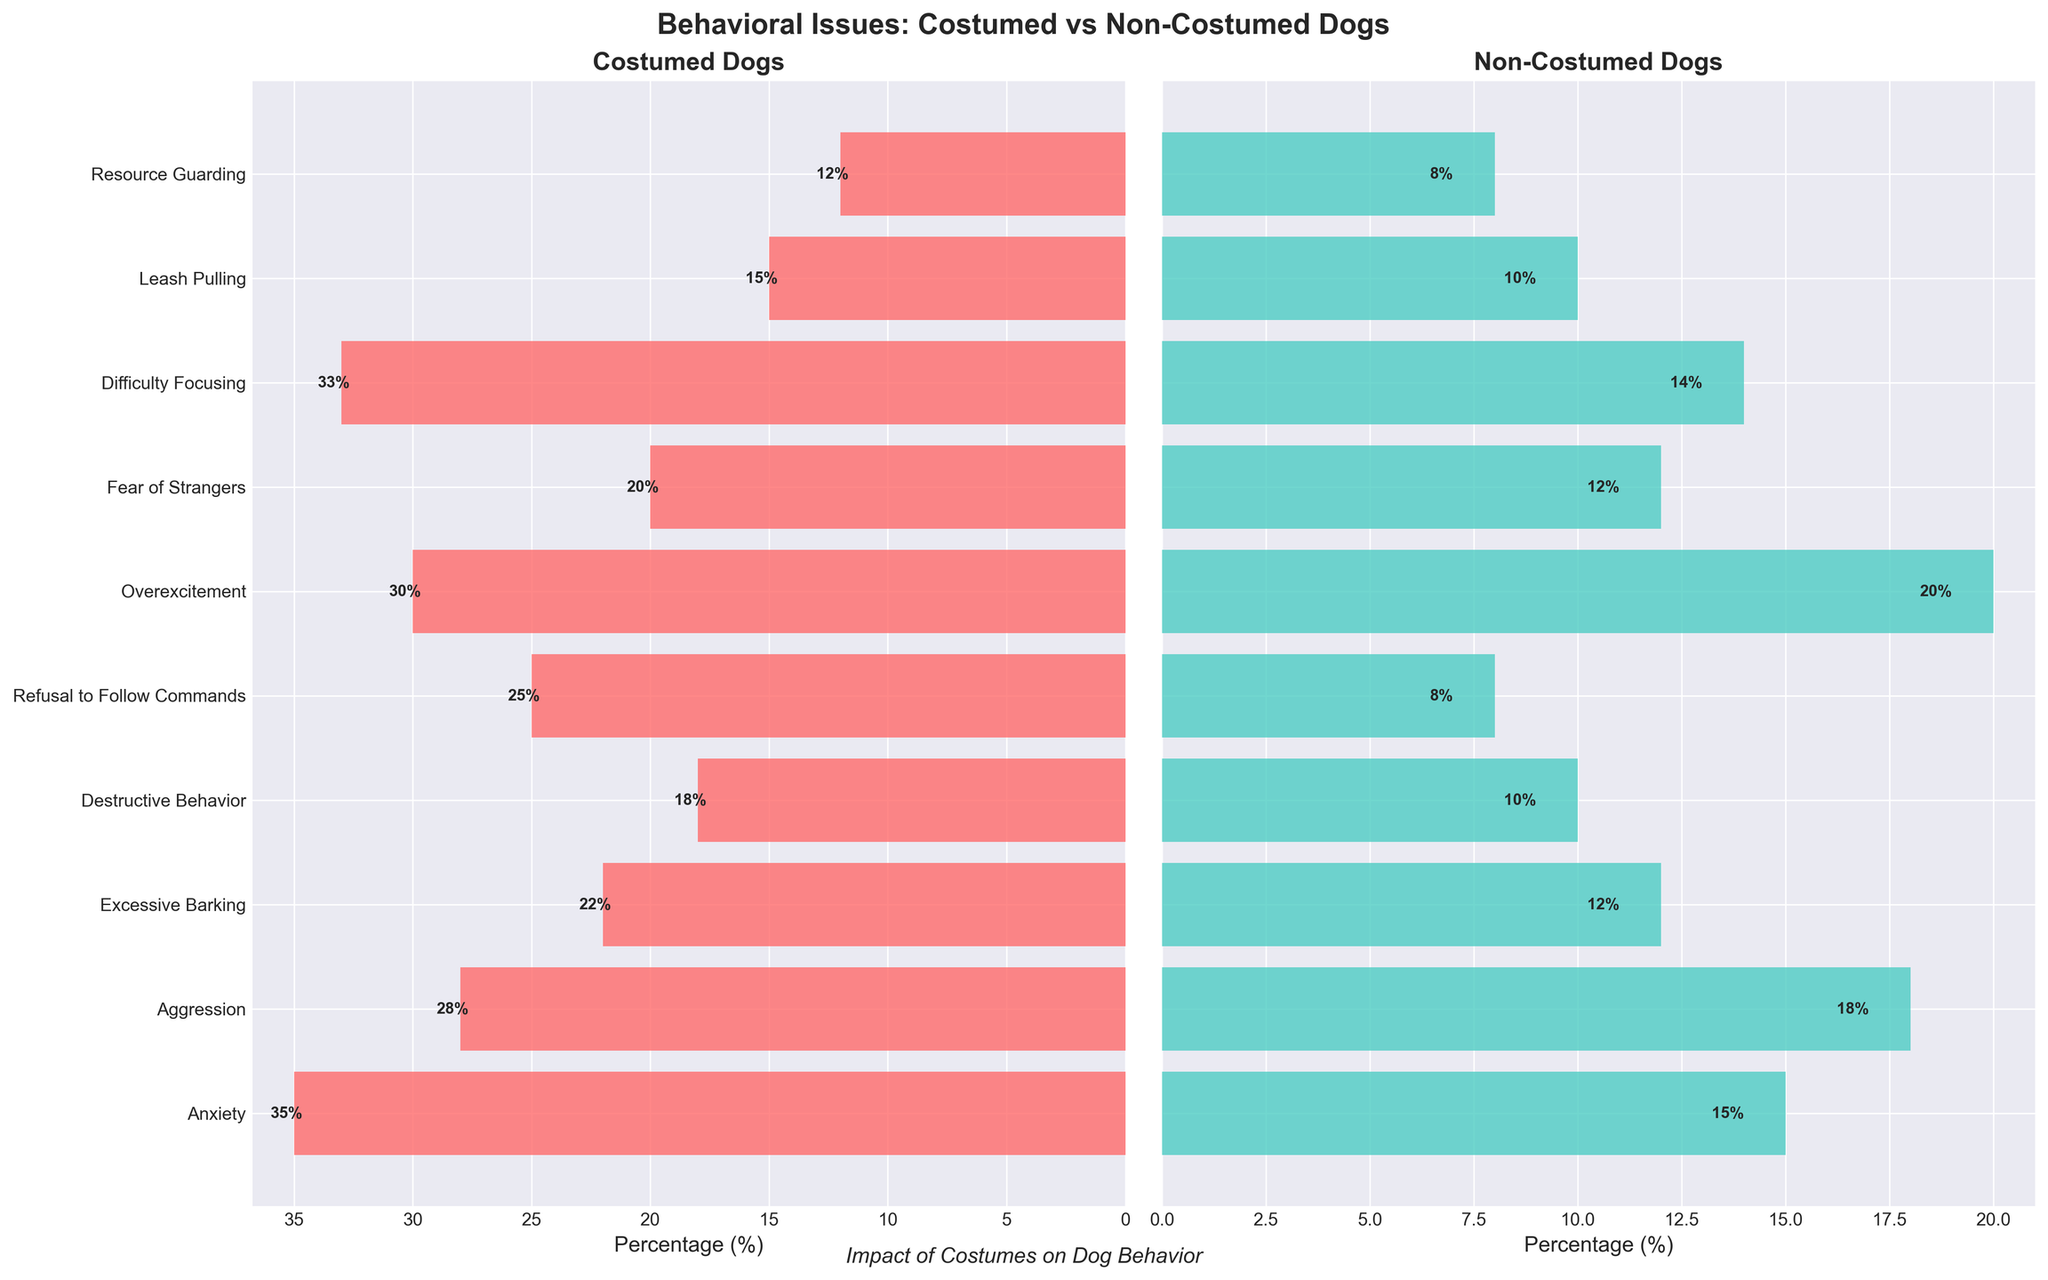What is the title of the figure? The title of the figure is written above the two subplots. It reads 'Behavioral Issues: Costumed vs Non-Costumed Dogs'.
Answer: Behavioral Issues: Costumed vs Non-Costumed Dogs What color represents costumed dogs in the figure? The legend or the bars themselves indicate that costumed dogs are represented by the color red.
Answer: Red Which behavioral issue has the highest percentage in costumed dogs? By looking at the lengths of the horizontal bars in the subplot for costumed dogs, we can see that 'Anxiety' has the longest bar, indicating the highest percentage of 35%.
Answer: Anxiety Which behavioral issue has the lowest percentage in non-costumed dogs? By looking at the horizontal bars in the subplot for non-costumed dogs, 'Resource Guarding' has the shortest bar, indicating the lowest percentage of 8%.
Answer: Resource Guarding How much greater is the percentage of 'Refusal to Follow Commands' in costumed dogs compared to non-costumed dogs? The percentage for 'Refusal to Follow Commands' in costumed dogs is 25%, and in non-costumed dogs it is 8%. The difference is calculated as 25% - 8% = 17%.
Answer: 17% What is the average percentage of behavioral issues reported for costumed dogs? Add the percentages for all behavioral issues for costumed dogs and divide by the number of issues: (35 + 28 + 22 + 18 + 25 + 30 + 20 + 33 + 15 + 12) / 10 = 23.8%.
Answer: 23.8% Which group has a greater percentage of dogs with 'Fear of Strangers' and by how much? The Fear of Strangers percentage in costumed dogs is 20%, and in non-costumed dogs it is 12%. So, the difference is 20% - 12% = 8%, indicating costumed dogs have a higher percentage.
Answer: Costumed dogs, 8% What is the total percentage of non-costumed dogs experiencing 'Aggression', 'Excessive Barking', and 'Destructive Behavior' combined? Add the percentages of Aggression (18%), Excessive Barking (12%), and Destructive Behavior (10%) for non-costumed dogs: 18% + 12% + 10% = 40%.
Answer: 40% In which group do dogs have a more significant percentage of 'Overexcitement'? Compare the Overexcitement percentages for both groups: costumed dogs have 30%, and non-costumed dogs have 20%. Thus, costumed dogs have a more significant percentage by 10%.
Answer: Costumed dogs How does the percentage of 'Difficulty Focusing' in costumed dogs compare to the same issue in non-costumed dogs? The percentage for Difficulty Focusing in costumed dogs is 33%, while it is 14% for non-costumed dogs. Costumed dogs show a higher percentage.
Answer: Costumed dogs 